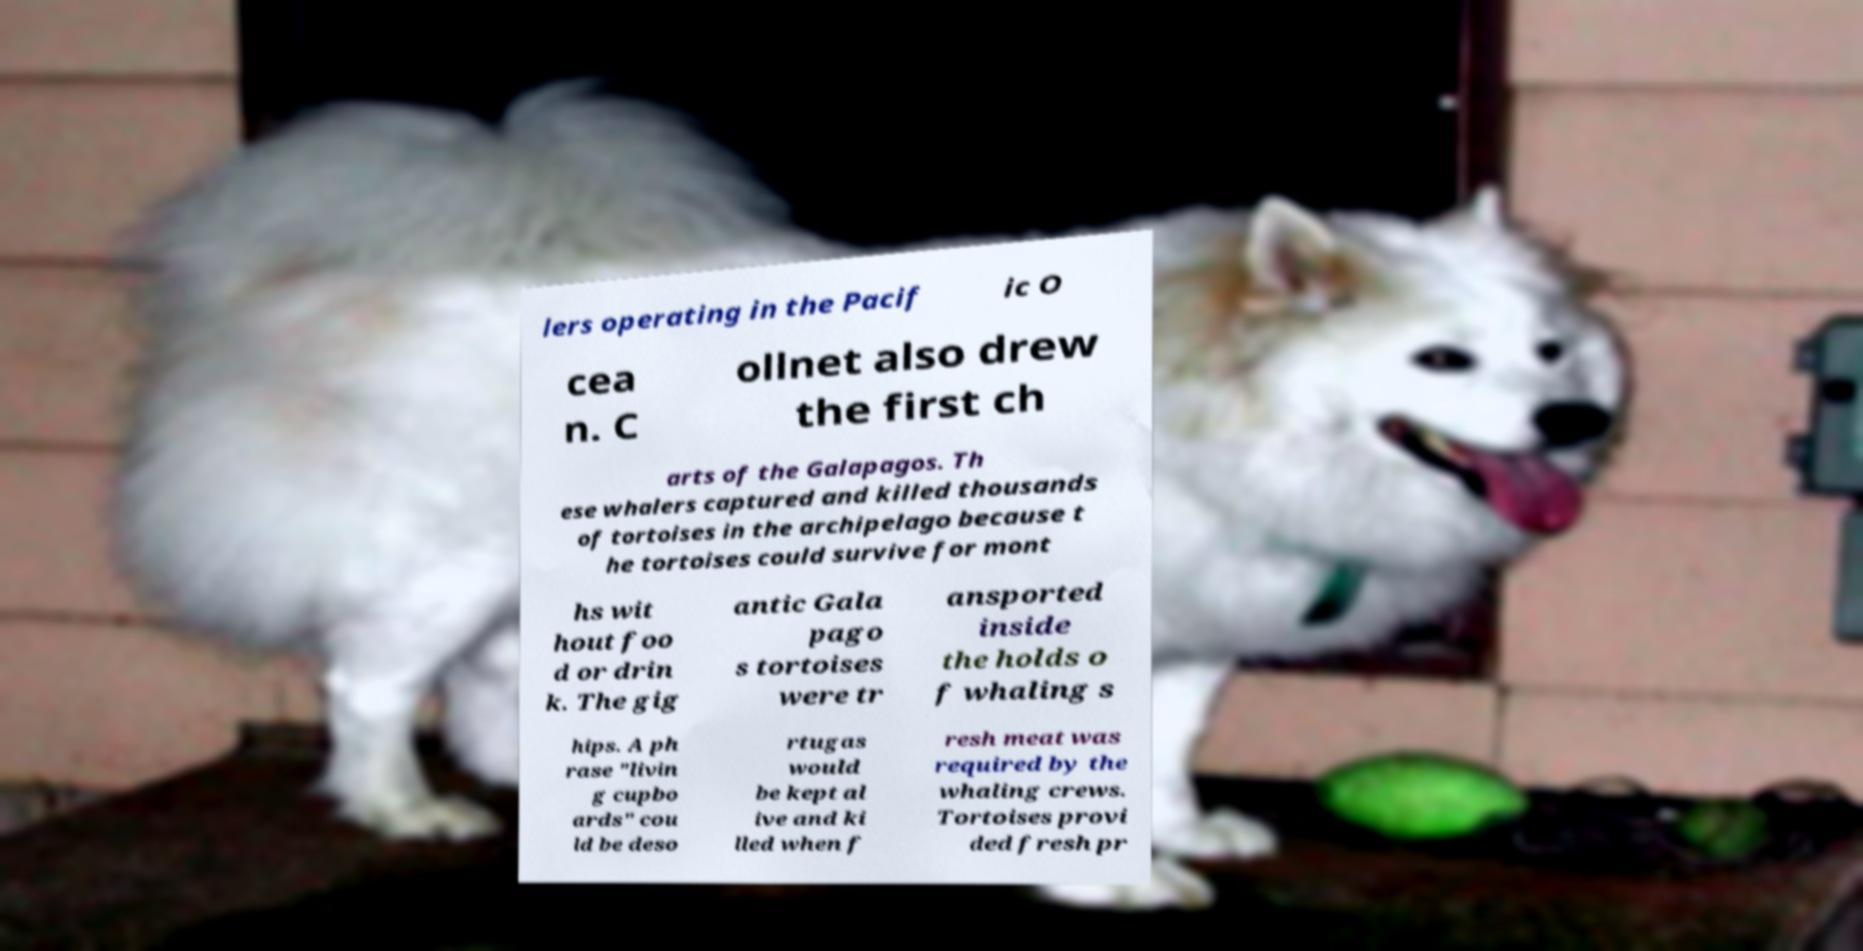Could you assist in decoding the text presented in this image and type it out clearly? lers operating in the Pacif ic O cea n. C ollnet also drew the first ch arts of the Galapagos. Th ese whalers captured and killed thousands of tortoises in the archipelago because t he tortoises could survive for mont hs wit hout foo d or drin k. The gig antic Gala pago s tortoises were tr ansported inside the holds o f whaling s hips. A ph rase "livin g cupbo ards" cou ld be deso rtugas would be kept al ive and ki lled when f resh meat was required by the whaling crews. Tortoises provi ded fresh pr 